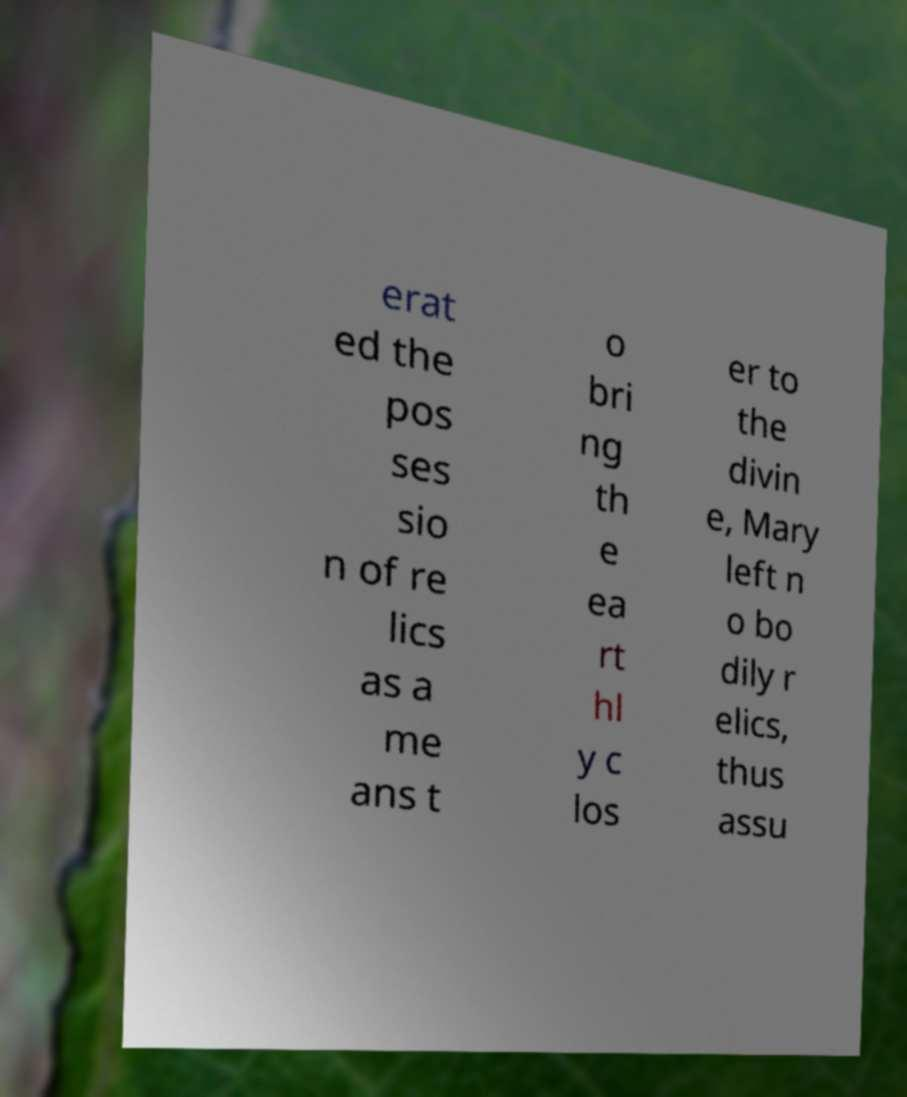Could you extract and type out the text from this image? erat ed the pos ses sio n of re lics as a me ans t o bri ng th e ea rt hl y c los er to the divin e, Mary left n o bo dily r elics, thus assu 